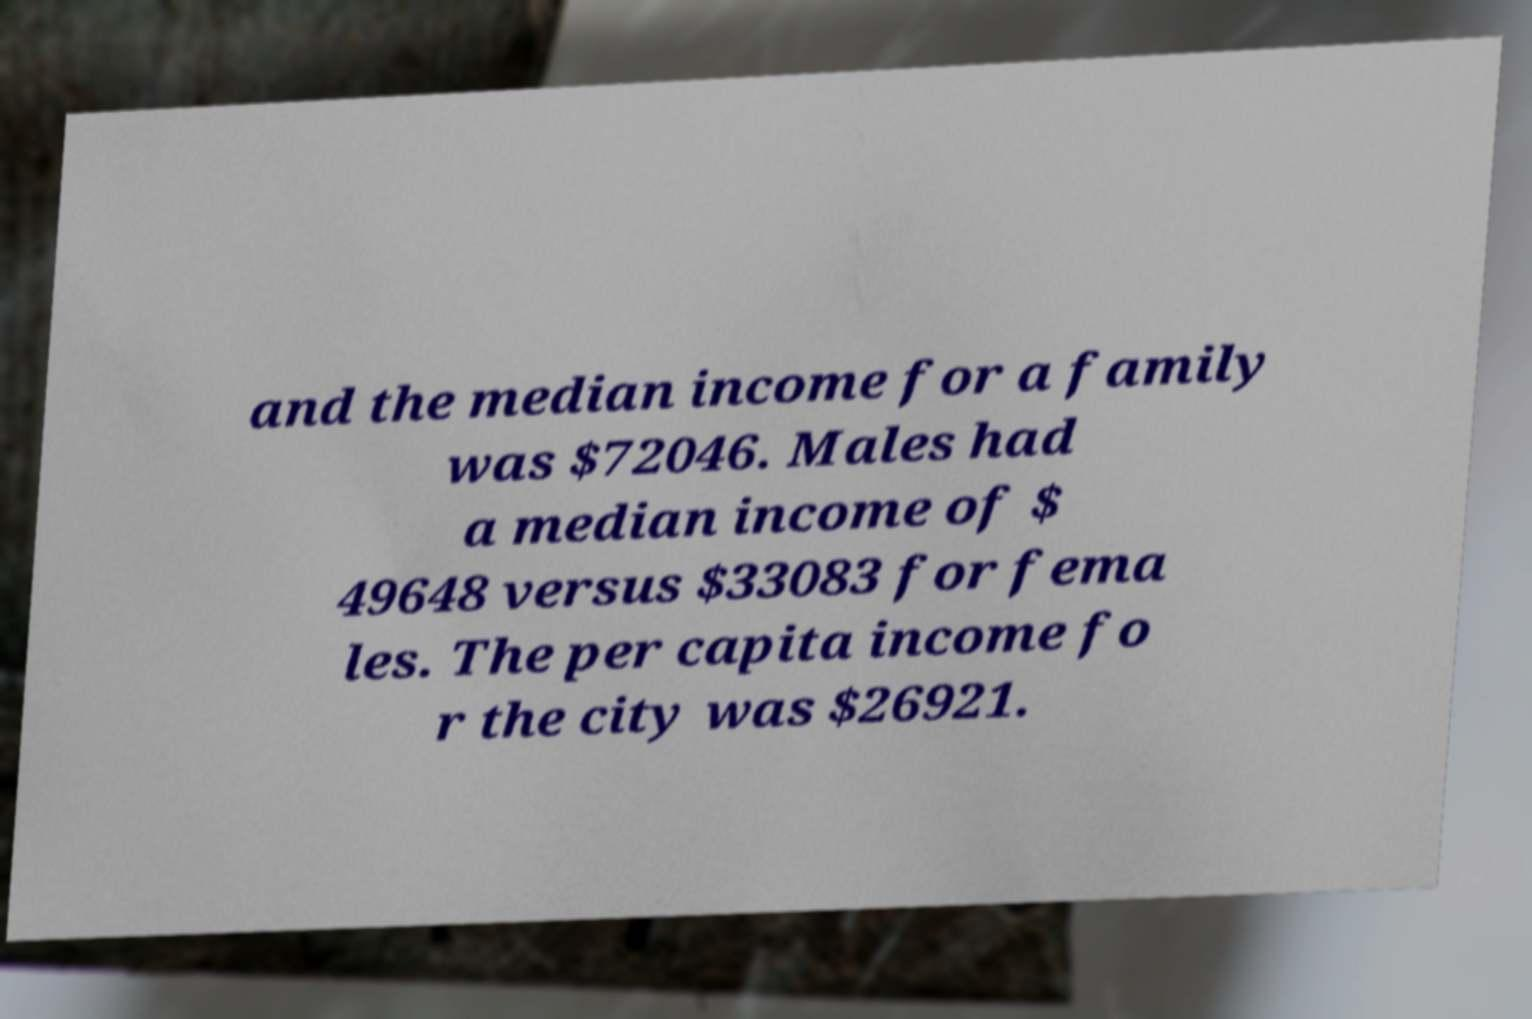Can you read and provide the text displayed in the image?This photo seems to have some interesting text. Can you extract and type it out for me? and the median income for a family was $72046. Males had a median income of $ 49648 versus $33083 for fema les. The per capita income fo r the city was $26921. 